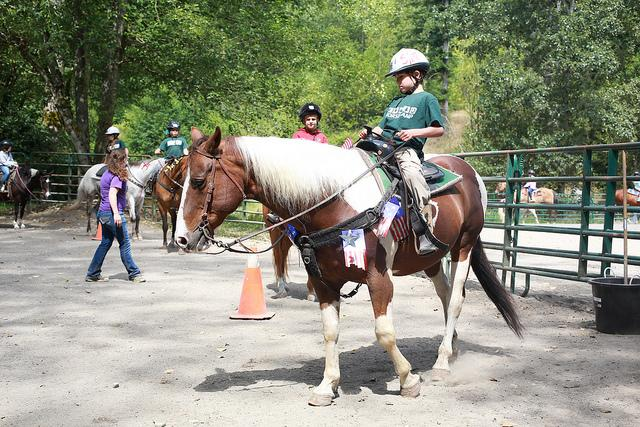Which person works at this facility? Please explain your reasoning. purple shirt. The person teaching the kids to ride is walking on foot. 